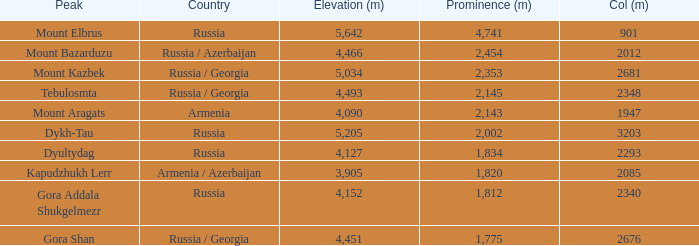What is the col (m) of peak mount aragats with an altitude (m) exceeding 3,905 and prominence below 2,143? None. 